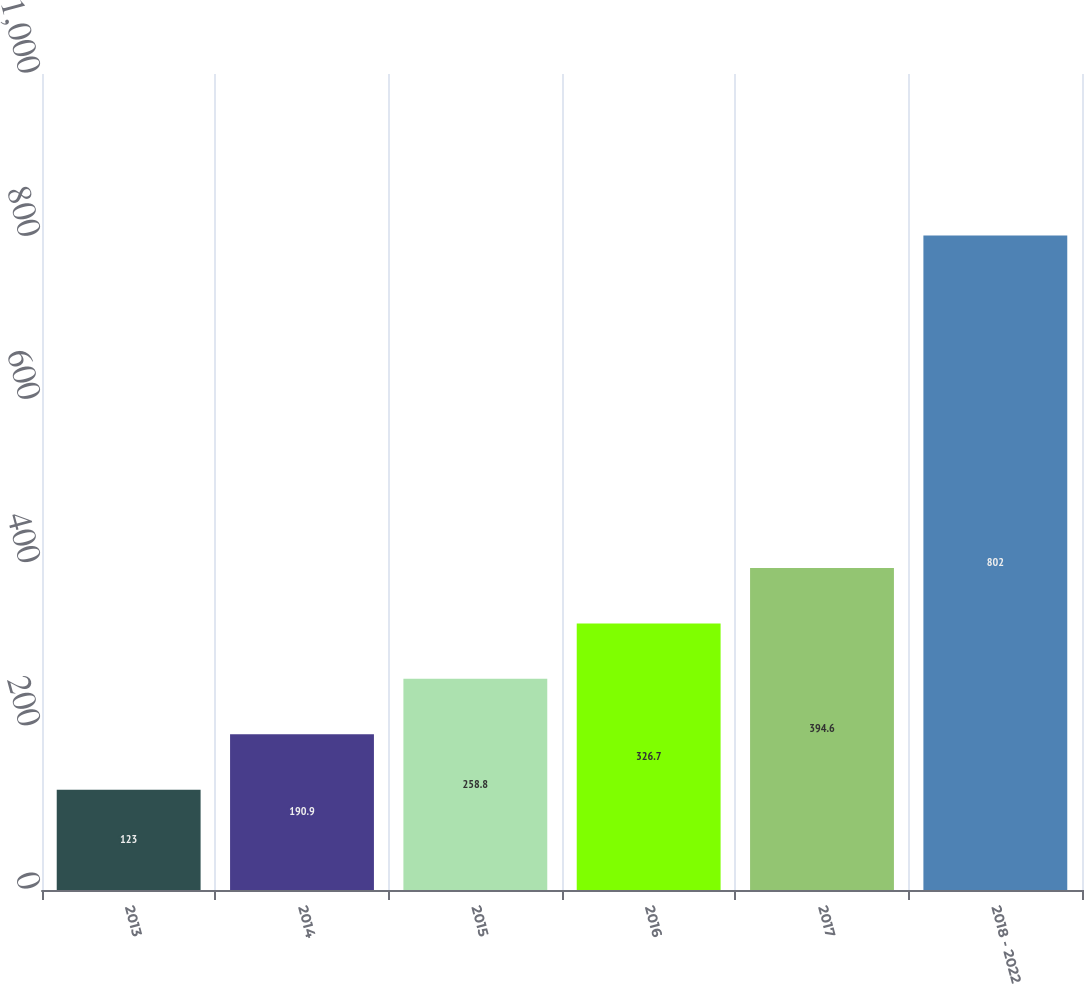Convert chart to OTSL. <chart><loc_0><loc_0><loc_500><loc_500><bar_chart><fcel>2013<fcel>2014<fcel>2015<fcel>2016<fcel>2017<fcel>2018 - 2022<nl><fcel>123<fcel>190.9<fcel>258.8<fcel>326.7<fcel>394.6<fcel>802<nl></chart> 